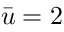<formula> <loc_0><loc_0><loc_500><loc_500>\bar { u } = 2</formula> 